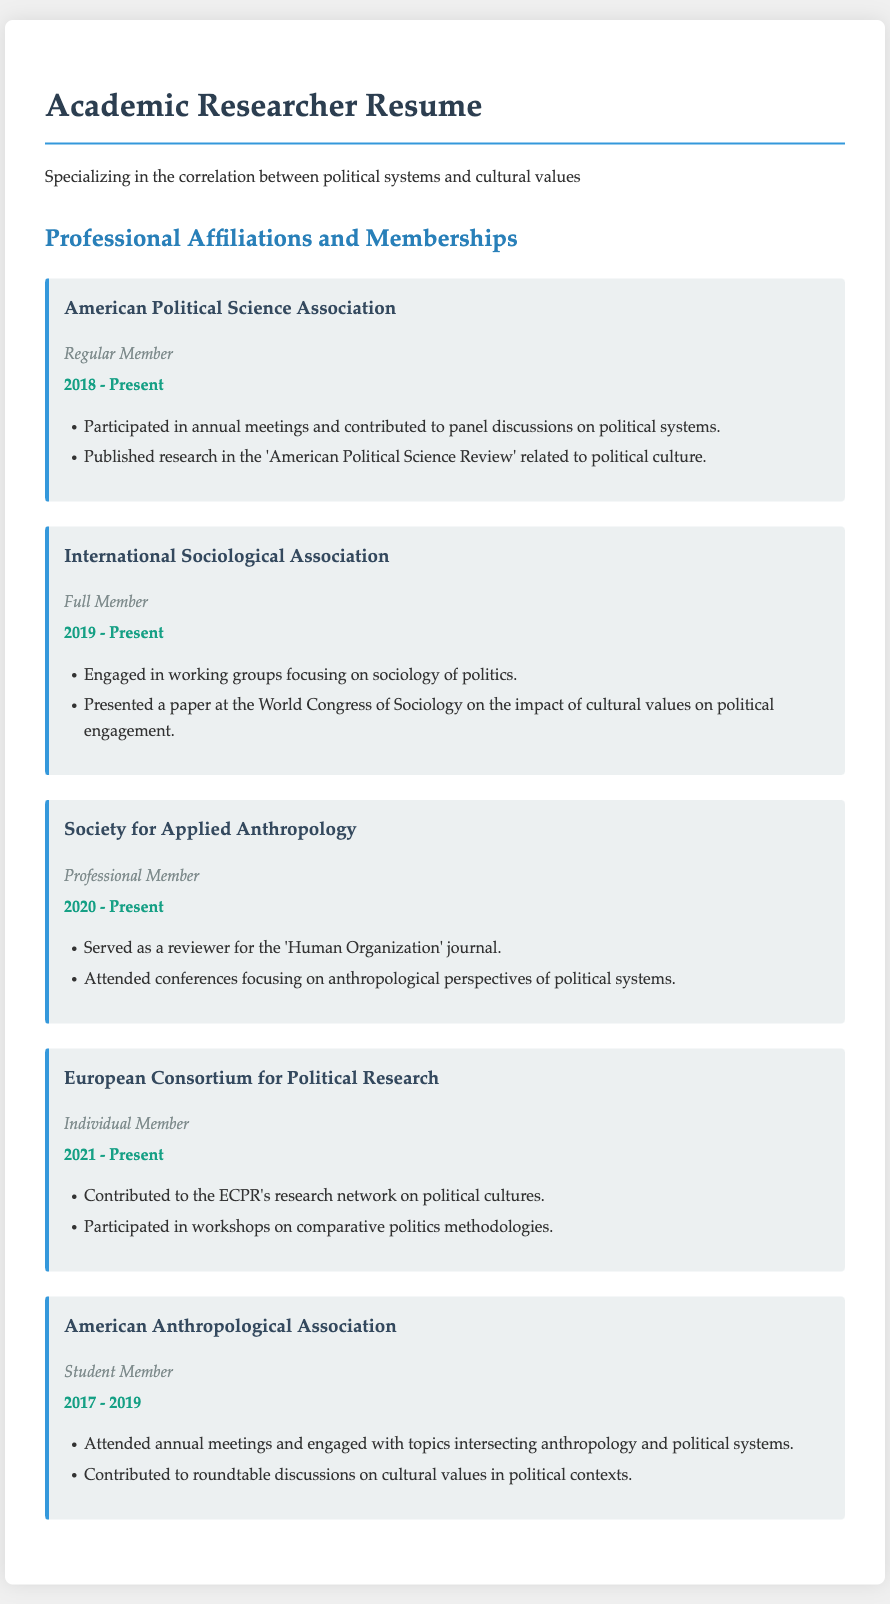What is the membership type for the American Political Science Association? The membership type for the American Political Science Association is listed in the document as "Regular Member."
Answer: Regular Member In which year did the researcher join the International Sociological Association? The document indicates that the researcher became a member of the International Sociological Association in 2019.
Answer: 2019 Which organization is focused on applied anthropology? The document mentions the "Society for Applied Anthropology" as the organization related to applied anthropology.
Answer: Society for Applied Anthropology How many years has the researcher been a member of the European Consortium for Political Research? The document states that the researcher has been a member since 2021, and since it is currently 2023, it has been 2 years.
Answer: 2 years What specific contributions did the researcher make to the American Anthropological Association as a student member? The document mentions contributions such as attending meetings and engaging with topics, showing active involvement during membership.
Answer: Engaged with topics intersecting anthropology and political systems What specific type of paper did the researcher present at the World Congress of Sociology? The document indicates that the researcher presented a paper on the impact of cultural values on political engagement.
Answer: Impact of cultural values on political engagement What research focus is emphasized by the European Consortium for Political Research membership? The document states that the researcher contributed to the research network on political cultures within the European Consortium for Political Research.
Answer: Political cultures What publication did the researcher contribute to while being a member of the American Political Science Association? The document states the researcher published research in the "American Political Science Review."
Answer: American Political Science Review What role did the researcher serve for the 'Human Organization' journal? The document indicates that the researcher served as a reviewer for the 'Human Organization' journal.
Answer: Reviewer 